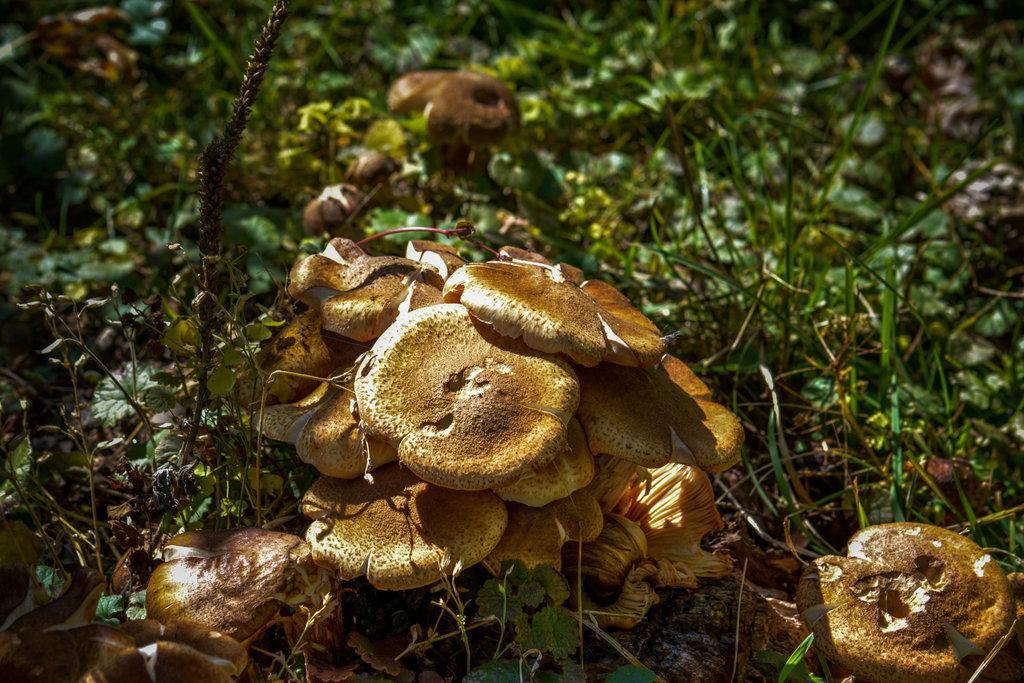Can you describe this image briefly? In this picture we can see mushrooms and grass. 